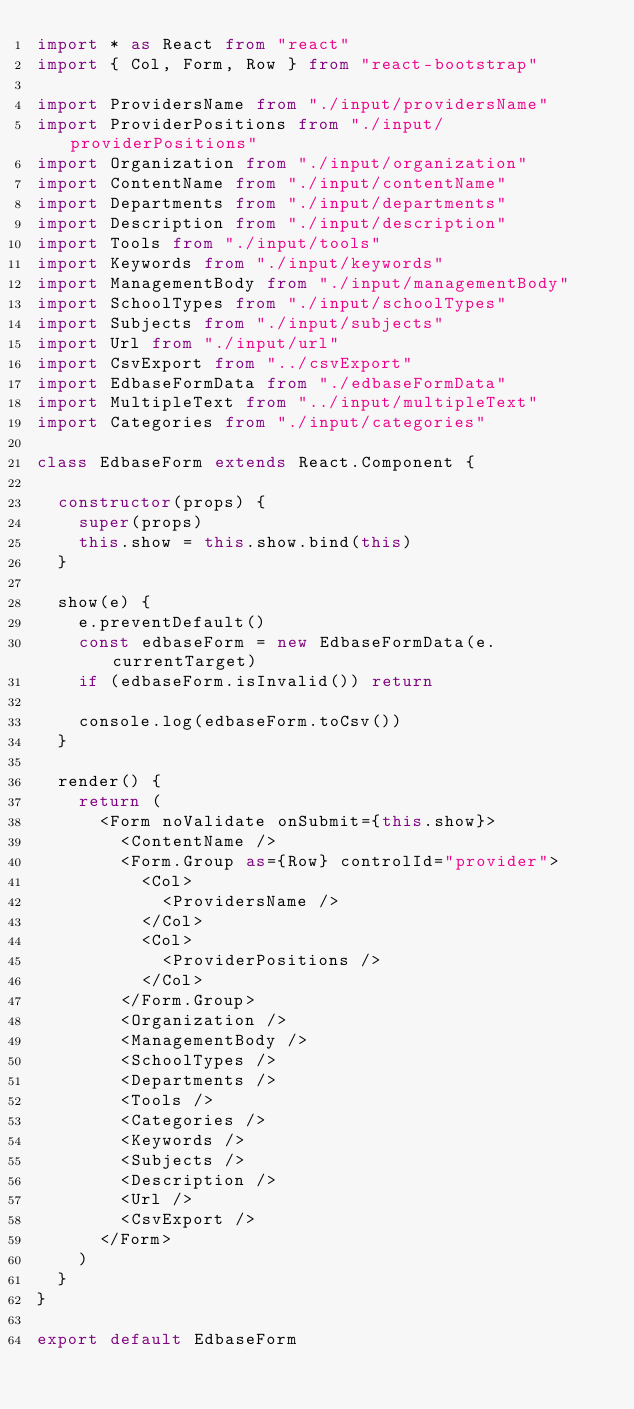Convert code to text. <code><loc_0><loc_0><loc_500><loc_500><_TypeScript_>import * as React from "react"
import { Col, Form, Row } from "react-bootstrap"

import ProvidersName from "./input/providersName"
import ProviderPositions from "./input/providerPositions"
import Organization from "./input/organization"
import ContentName from "./input/contentName"
import Departments from "./input/departments"
import Description from "./input/description"
import Tools from "./input/tools"
import Keywords from "./input/keywords"
import ManagementBody from "./input/managementBody"
import SchoolTypes from "./input/schoolTypes"
import Subjects from "./input/subjects"
import Url from "./input/url"
import CsvExport from "../csvExport"
import EdbaseFormData from "./edbaseFormData"
import MultipleText from "../input/multipleText"
import Categories from "./input/categories"

class EdbaseForm extends React.Component {

  constructor(props) {
    super(props)
    this.show = this.show.bind(this)
  }

  show(e) {
    e.preventDefault()
    const edbaseForm = new EdbaseFormData(e.currentTarget)
    if (edbaseForm.isInvalid()) return

    console.log(edbaseForm.toCsv())
  }

  render() {
    return (
      <Form noValidate onSubmit={this.show}>
        <ContentName />
        <Form.Group as={Row} controlId="provider">
          <Col>
            <ProvidersName />
          </Col>
          <Col>
            <ProviderPositions />
          </Col>
        </Form.Group>
        <Organization />
        <ManagementBody />
        <SchoolTypes />
        <Departments />
        <Tools />
        <Categories />
        <Keywords />
        <Subjects />
        <Description />
        <Url />
        <CsvExport />
      </Form>
    )
  }
}

export default EdbaseForm
</code> 